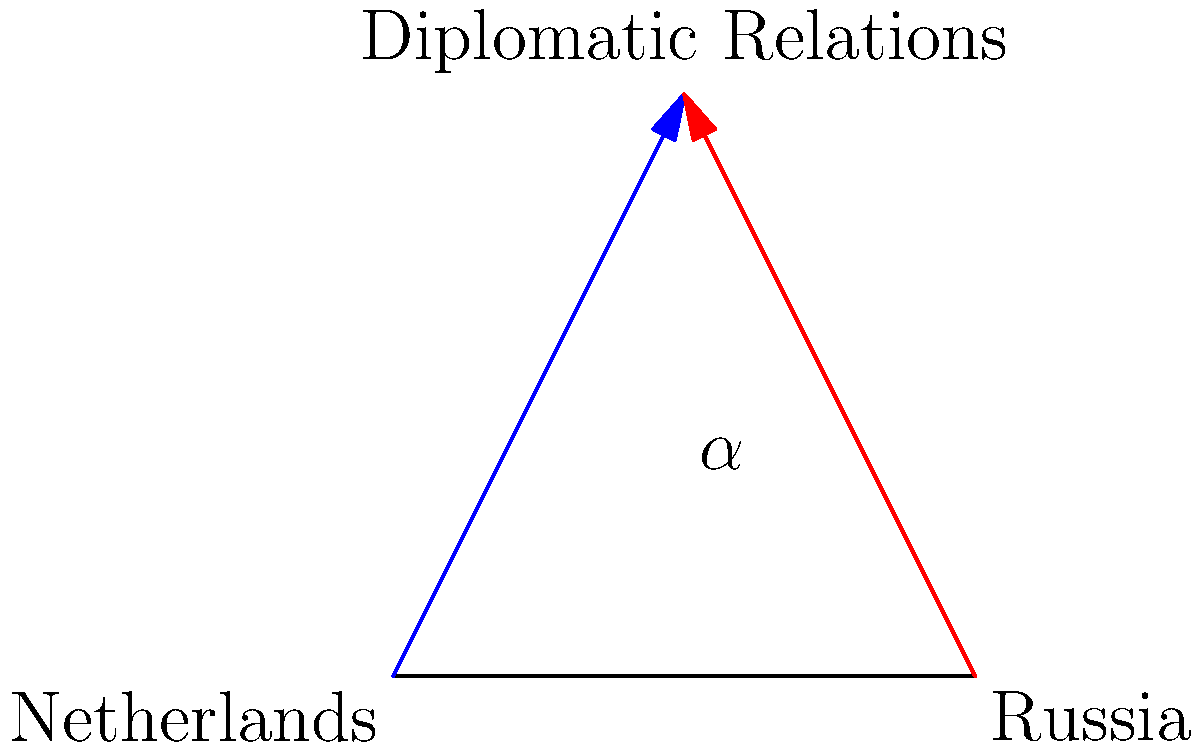In the diagram, two lines represent diplomatic relations between the Netherlands and Russia, intersecting at a point symbolizing their interactions. If the angle formed by these lines is $\alpha$, and it is known that $\tan(\alpha) = \frac{4}{3}$, what is the value of $\sin(\alpha)$? To find $\sin(\alpha)$ given $\tan(\alpha) = \frac{4}{3}$, we can follow these steps:

1) Recall the trigonometric identity: $\tan^2(\alpha) + 1 = \sec^2(\alpha)$

2) Substitute the given value: $(\frac{4}{3})^2 + 1 = \sec^2(\alpha)$

3) Simplify: $\frac{16}{9} + 1 = \sec^2(\alpha)$
             $\frac{25}{9} = \sec^2(\alpha)$

4) Take the square root of both sides: $\frac{5}{3} = \sec(\alpha)$

5) Recall another identity: $\sin^2(\alpha) + \cos^2(\alpha) = 1$

6) And: $\cos(\alpha) = \frac{1}{\sec(\alpha)}$

7) So: $\cos(\alpha) = \frac{3}{5}$

8) Substitute into the identity from step 5:
   $\sin^2(\alpha) + (\frac{3}{5})^2 = 1$

9) Solve for $\sin^2(\alpha)$:
   $\sin^2(\alpha) = 1 - \frac{9}{25} = \frac{16}{25}$

10) Take the square root:
    $\sin(\alpha) = \frac{4}{5}$

Therefore, $\sin(\alpha) = \frac{4}{5}$.
Answer: $\frac{4}{5}$ 